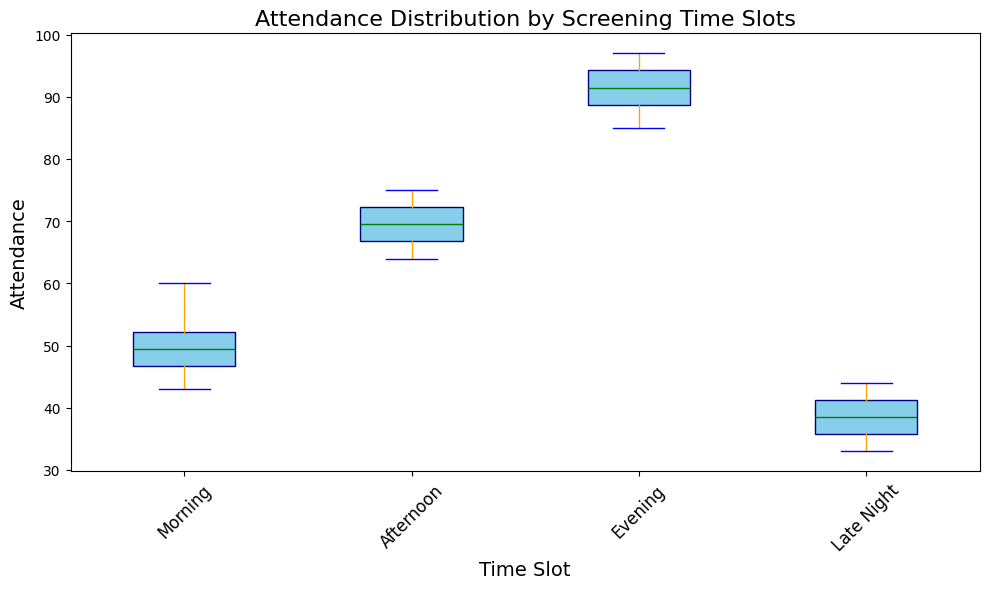Which time slot has the highest median attendance? The box plot shows the median value as a horizontal line inside each box. The Evening slot has the highest median attendance, with the median line situated around 91.
Answer: Evening Which time slot has the lowest Attendance range? The range is determined by the difference between the minimum and maximum values of the whiskers. The Morning slot shows the smallest range, with whiskers from about 43 to 60.
Answer: Morning What is the interquartile range (IQR) for the Afternoon slot? The IQR is the difference between the 75th percentile (upper edge of the box) and the 25th percentile (lower edge of the box). For the Afternoon slot, the lower quartile is around 66 and the upper quartile is around 73, so IQR is 73 - 66 = 7.
Answer: 7 Which time slot shows the most variability in attendance? Variability can be seen by the height of the box and the whiskers. The Evening slot shows the most variability with whiskers ranging from about 85 to 97.
Answer: Evening Are there any outliers in the data, and if so, in which time slots? Outliers in a box plot are indicated by individual points outside the whiskers. There are no outliers depicted as red points in the generated box plot.
Answer: No Is the median attendance higher in the Morning or Late Night slot? The horizontal lines in the boxes indicate the median. The Morning slot has a median near 50 while the Late Night slot has a median around 38, showing that Morning is higher.
Answer: Morning How does the median attendance in the Morning compare to the Afternoon slot? Comparing the central horizontal lines in the boxes, the Afternoon slot has a median around 70 while the Morning slot has a median around 50. The Afternoon median is higher.
Answer: Afternoon What is the maximum attendance recorded in the Evening slot? The top whisker of the Evening slot indicates the maximum attendance value, which reaches approximately 97.
Answer: 97 Considering the interquartile ranges, which time slot’s attendance is more concentrated around the median? A smaller IQR indicates more concentration around the median. The Morning slot has the smallest IQR, suggesting its attendance is more concentrated around the median.
Answer: Morning 